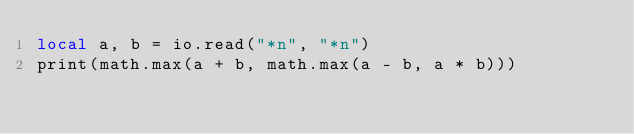Convert code to text. <code><loc_0><loc_0><loc_500><loc_500><_Lua_>local a, b = io.read("*n", "*n")
print(math.max(a + b, math.max(a - b, a * b)))
</code> 